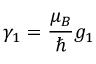<formula> <loc_0><loc_0><loc_500><loc_500>\gamma _ { 1 } = \frac { \mu _ { B } } { } g _ { 1 }</formula> 